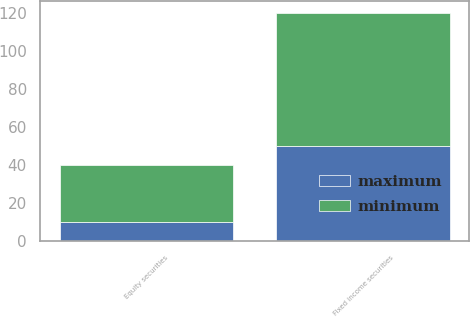Convert chart. <chart><loc_0><loc_0><loc_500><loc_500><stacked_bar_chart><ecel><fcel>Equity securities<fcel>Fixed income securities<nl><fcel>maximum<fcel>10<fcel>50<nl><fcel>minimum<fcel>30<fcel>70<nl></chart> 